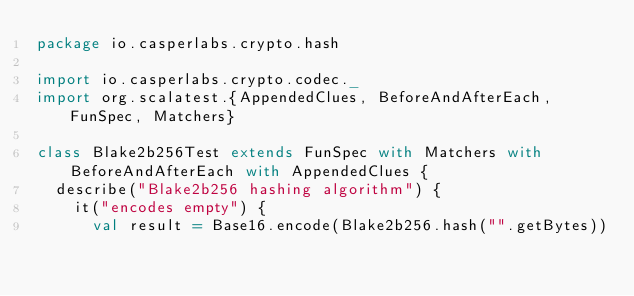<code> <loc_0><loc_0><loc_500><loc_500><_Scala_>package io.casperlabs.crypto.hash

import io.casperlabs.crypto.codec._
import org.scalatest.{AppendedClues, BeforeAndAfterEach, FunSpec, Matchers}

class Blake2b256Test extends FunSpec with Matchers with BeforeAndAfterEach with AppendedClues {
  describe("Blake2b256 hashing algorithm") {
    it("encodes empty") {
      val result = Base16.encode(Blake2b256.hash("".getBytes))</code> 